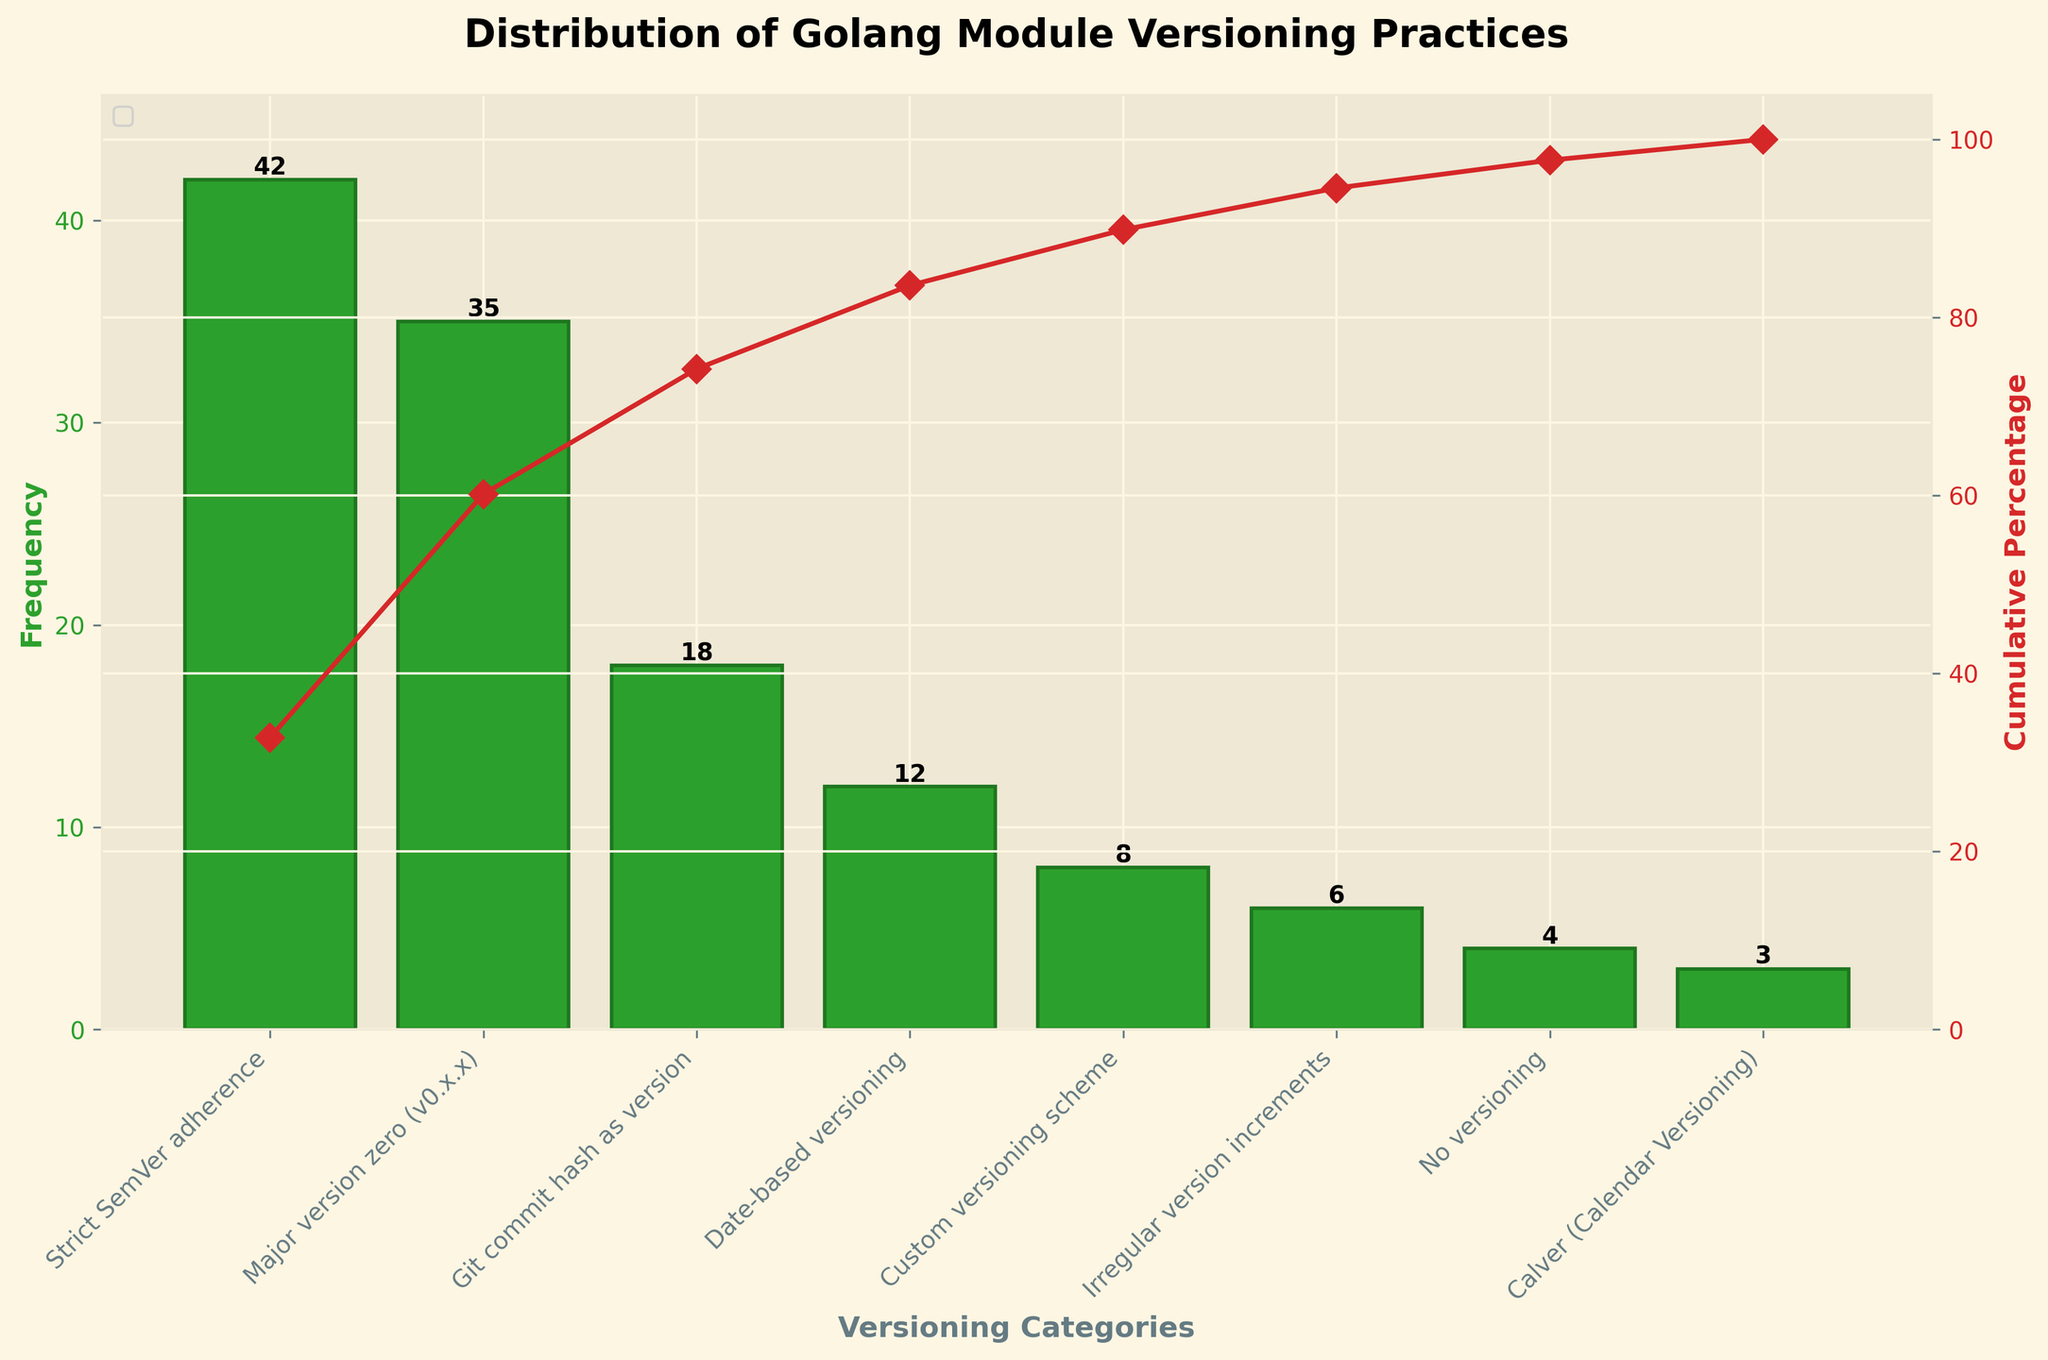How many versioning categories are there in total? The x-axis lists all the versioning categories. Count the number of distinct categories displayed on the x-axis.
Answer: 8 Which versioning practice is most common among Golang open-source projects? The highest bar in the bar chart represents the most common versioning practice. This bar corresponds to "Strict SemVer adherence."
Answer: Strict SemVer adherence What is the cumulative percentage when you reach the third most common versioning practice? Identify the bars according to their frequencies: the third bar corresponds to "Git commit hash as version." Refer to the line plot to see the cumulative percentage at this point.
Answer: 75% Which versioning practices have a frequency of less than 10? Look at the height of each bar representing the versioning practices. Identify those bars that are below the value of 10 on the y-axis. These practices are "Custom versioning scheme," "Irregular version increments," "No versioning," and "Calver (Calendar Versioning)."
Answer: Custom versioning scheme, Irregular version increments, No versioning, Calver (Calendar Versioning) By how much does "Major version zero (v0.x.x)" exceed "Date-based versioning" in frequency? Look at the bars corresponding to "Major version zero (v0.x.x)" and "Date-based versioning." Subtract the frequency of "Date-based versioning" from that of "Major version zero."
Answer: 23 Which versioning practices together account for more than 50% of the cumulative percentage? Examine the cumulative percentage line and identify which data points cross the 50% mark. The corresponding categories before and at this crossing point are "Strict SemVer adherence," "Major version zero (v0.x.x)," and "Git commit hash as version."
Answer: Strict SemVer adherence, Major version zero (v0.x.x), Git commit hash as version What percentage of projects use "No versioning"? Find the bar labeled "No versioning" and refer to its height to determine its frequency. Then calculate its percentage by dividing this frequency by the total sum of all frequencies and multiplying by 100. The displayed height is 4, and total frequency is 128. So, (4/128) * 100.
Answer: 3.1% What is the combined total frequency of "Custom versioning scheme" and "Date-based versioning"? Look at the bars for "Custom versioning scheme" and "Date-based versioning." Add their frequencies together: 8 (Custom versioning scheme) + 12 (Date-based versioning).
Answer: 20 